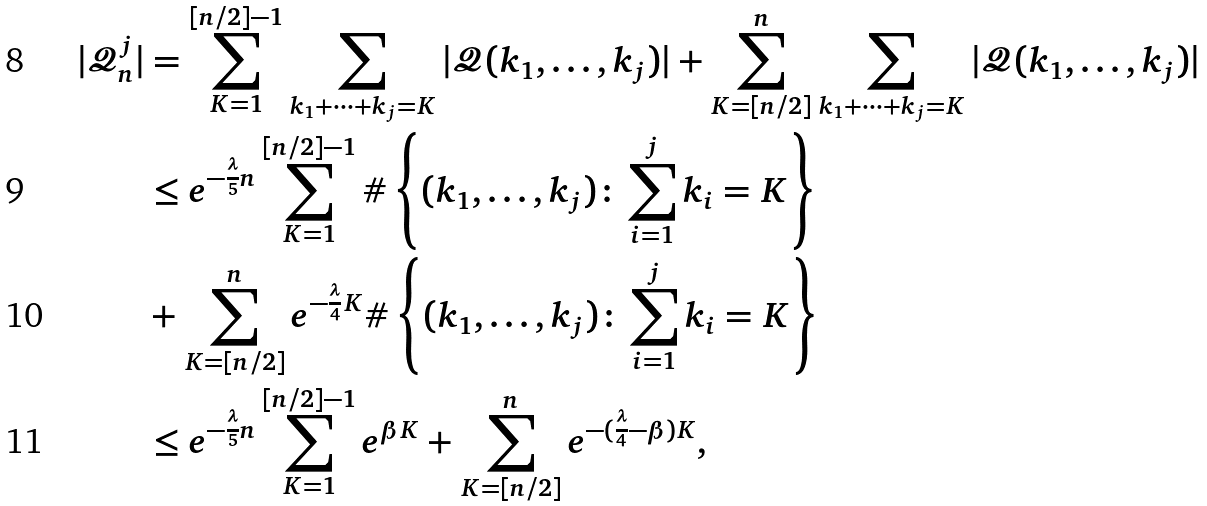Convert formula to latex. <formula><loc_0><loc_0><loc_500><loc_500>| \mathcal { Q } _ { n } ^ { j } | & = \sum _ { K = 1 } ^ { [ n / 2 ] - 1 } \sum _ { k _ { 1 } + \cdots + k _ { j } = K } | \mathcal { Q } ( k _ { 1 } , \dots , k _ { j } ) | + \sum _ { K = [ n / 2 ] } ^ { n } \sum _ { k _ { 1 } + \cdots + k _ { j } = K } | \mathcal { Q } ( k _ { 1 } , \dots , k _ { j } ) | \\ & \leq e ^ { - \frac { \lambda } { 5 } n } \sum _ { K = 1 } ^ { [ n / 2 ] - 1 } \# \left \{ ( k _ { 1 } , \dots , k _ { j } ) \colon \sum _ { i = 1 } ^ { j } k _ { i } = K \right \} \\ & + \sum _ { K = [ n / 2 ] } ^ { n } e ^ { - \frac { \lambda } { 4 } K } \# \left \{ ( k _ { 1 } , \dots , k _ { j } ) \colon \sum _ { i = 1 } ^ { j } k _ { i } = K \right \} \\ & \leq e ^ { - \frac { \lambda } { 5 } n } \sum _ { K = 1 } ^ { [ n / 2 ] - 1 } e ^ { \beta K } + \sum _ { K = [ n / 2 ] } ^ { n } e ^ { - ( \frac { \lambda } { 4 } - \beta ) K } ,</formula> 